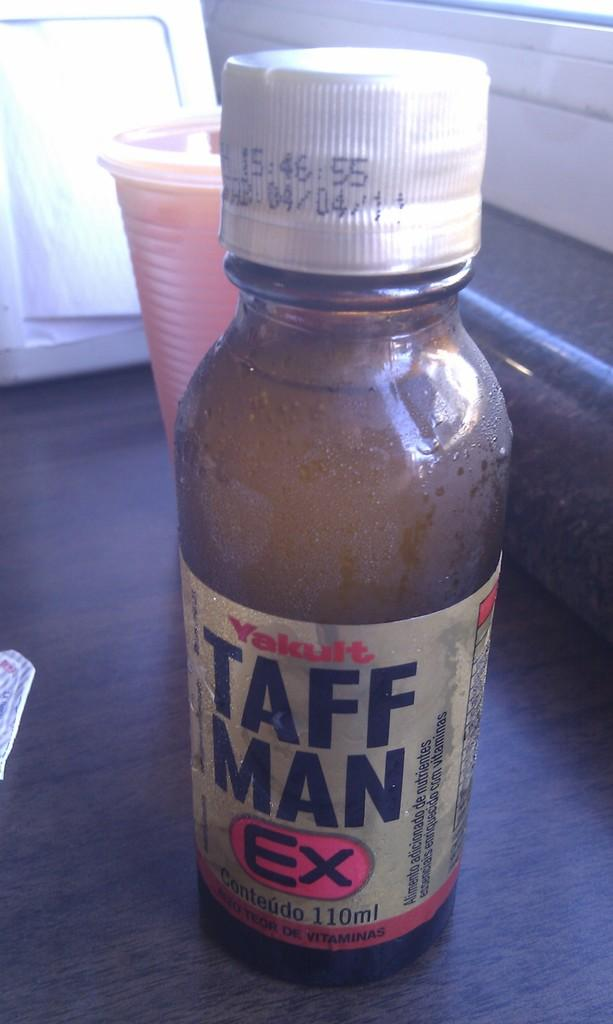<image>
Describe the image concisely. A medicine vial labeled Yakult Taff Man EX. 